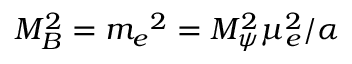Convert formula to latex. <formula><loc_0><loc_0><loc_500><loc_500>M _ { B } ^ { 2 } = m _ { e ^ { 2 } = M _ { \psi } ^ { 2 } \mu _ { e } ^ { 2 } / \alpha</formula> 